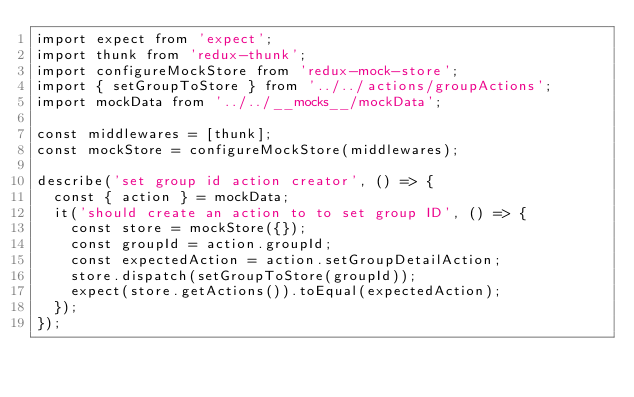Convert code to text. <code><loc_0><loc_0><loc_500><loc_500><_JavaScript_>import expect from 'expect';
import thunk from 'redux-thunk';
import configureMockStore from 'redux-mock-store';
import { setGroupToStore } from '../../actions/groupActions';
import mockData from '../../__mocks__/mockData';

const middlewares = [thunk];
const mockStore = configureMockStore(middlewares);

describe('set group id action creator', () => {
  const { action } = mockData;
  it('should create an action to to set group ID', () => {
    const store = mockStore({});
    const groupId = action.groupId;
    const expectedAction = action.setGroupDetailAction;
    store.dispatch(setGroupToStore(groupId));
    expect(store.getActions()).toEqual(expectedAction);
  });
});
</code> 